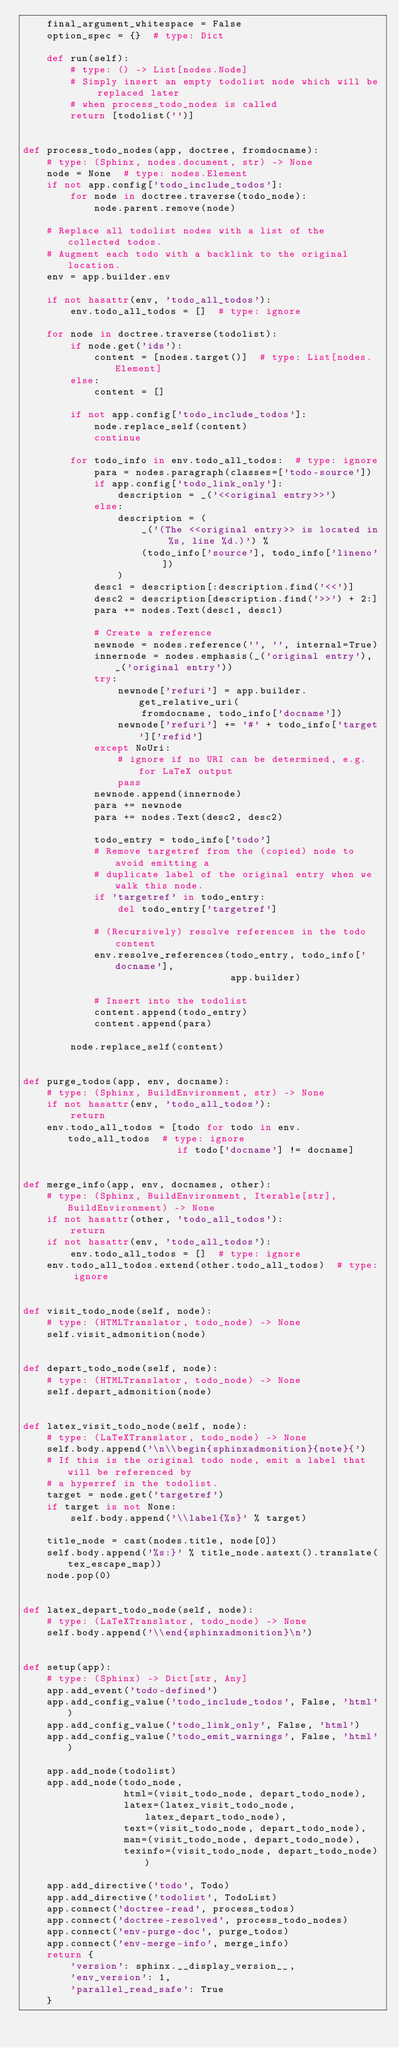<code> <loc_0><loc_0><loc_500><loc_500><_Python_>    final_argument_whitespace = False
    option_spec = {}  # type: Dict

    def run(self):
        # type: () -> List[nodes.Node]
        # Simply insert an empty todolist node which will be replaced later
        # when process_todo_nodes is called
        return [todolist('')]


def process_todo_nodes(app, doctree, fromdocname):
    # type: (Sphinx, nodes.document, str) -> None
    node = None  # type: nodes.Element
    if not app.config['todo_include_todos']:
        for node in doctree.traverse(todo_node):
            node.parent.remove(node)

    # Replace all todolist nodes with a list of the collected todos.
    # Augment each todo with a backlink to the original location.
    env = app.builder.env

    if not hasattr(env, 'todo_all_todos'):
        env.todo_all_todos = []  # type: ignore

    for node in doctree.traverse(todolist):
        if node.get('ids'):
            content = [nodes.target()]  # type: List[nodes.Element]
        else:
            content = []

        if not app.config['todo_include_todos']:
            node.replace_self(content)
            continue

        for todo_info in env.todo_all_todos:  # type: ignore
            para = nodes.paragraph(classes=['todo-source'])
            if app.config['todo_link_only']:
                description = _('<<original entry>>')
            else:
                description = (
                    _('(The <<original entry>> is located in %s, line %d.)') %
                    (todo_info['source'], todo_info['lineno'])
                )
            desc1 = description[:description.find('<<')]
            desc2 = description[description.find('>>') + 2:]
            para += nodes.Text(desc1, desc1)

            # Create a reference
            newnode = nodes.reference('', '', internal=True)
            innernode = nodes.emphasis(_('original entry'), _('original entry'))
            try:
                newnode['refuri'] = app.builder.get_relative_uri(
                    fromdocname, todo_info['docname'])
                newnode['refuri'] += '#' + todo_info['target']['refid']
            except NoUri:
                # ignore if no URI can be determined, e.g. for LaTeX output
                pass
            newnode.append(innernode)
            para += newnode
            para += nodes.Text(desc2, desc2)

            todo_entry = todo_info['todo']
            # Remove targetref from the (copied) node to avoid emitting a
            # duplicate label of the original entry when we walk this node.
            if 'targetref' in todo_entry:
                del todo_entry['targetref']

            # (Recursively) resolve references in the todo content
            env.resolve_references(todo_entry, todo_info['docname'],
                                   app.builder)

            # Insert into the todolist
            content.append(todo_entry)
            content.append(para)

        node.replace_self(content)


def purge_todos(app, env, docname):
    # type: (Sphinx, BuildEnvironment, str) -> None
    if not hasattr(env, 'todo_all_todos'):
        return
    env.todo_all_todos = [todo for todo in env.todo_all_todos  # type: ignore
                          if todo['docname'] != docname]


def merge_info(app, env, docnames, other):
    # type: (Sphinx, BuildEnvironment, Iterable[str], BuildEnvironment) -> None
    if not hasattr(other, 'todo_all_todos'):
        return
    if not hasattr(env, 'todo_all_todos'):
        env.todo_all_todos = []  # type: ignore
    env.todo_all_todos.extend(other.todo_all_todos)  # type: ignore


def visit_todo_node(self, node):
    # type: (HTMLTranslator, todo_node) -> None
    self.visit_admonition(node)


def depart_todo_node(self, node):
    # type: (HTMLTranslator, todo_node) -> None
    self.depart_admonition(node)


def latex_visit_todo_node(self, node):
    # type: (LaTeXTranslator, todo_node) -> None
    self.body.append('\n\\begin{sphinxadmonition}{note}{')
    # If this is the original todo node, emit a label that will be referenced by
    # a hyperref in the todolist.
    target = node.get('targetref')
    if target is not None:
        self.body.append('\\label{%s}' % target)

    title_node = cast(nodes.title, node[0])
    self.body.append('%s:}' % title_node.astext().translate(tex_escape_map))
    node.pop(0)


def latex_depart_todo_node(self, node):
    # type: (LaTeXTranslator, todo_node) -> None
    self.body.append('\\end{sphinxadmonition}\n')


def setup(app):
    # type: (Sphinx) -> Dict[str, Any]
    app.add_event('todo-defined')
    app.add_config_value('todo_include_todos', False, 'html')
    app.add_config_value('todo_link_only', False, 'html')
    app.add_config_value('todo_emit_warnings', False, 'html')

    app.add_node(todolist)
    app.add_node(todo_node,
                 html=(visit_todo_node, depart_todo_node),
                 latex=(latex_visit_todo_node, latex_depart_todo_node),
                 text=(visit_todo_node, depart_todo_node),
                 man=(visit_todo_node, depart_todo_node),
                 texinfo=(visit_todo_node, depart_todo_node))

    app.add_directive('todo', Todo)
    app.add_directive('todolist', TodoList)
    app.connect('doctree-read', process_todos)
    app.connect('doctree-resolved', process_todo_nodes)
    app.connect('env-purge-doc', purge_todos)
    app.connect('env-merge-info', merge_info)
    return {
        'version': sphinx.__display_version__,
        'env_version': 1,
        'parallel_read_safe': True
    }
</code> 